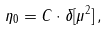<formula> <loc_0><loc_0><loc_500><loc_500>\eta _ { 0 } = C \cdot \delta [ \mu ^ { 2 } ] \, ,</formula> 